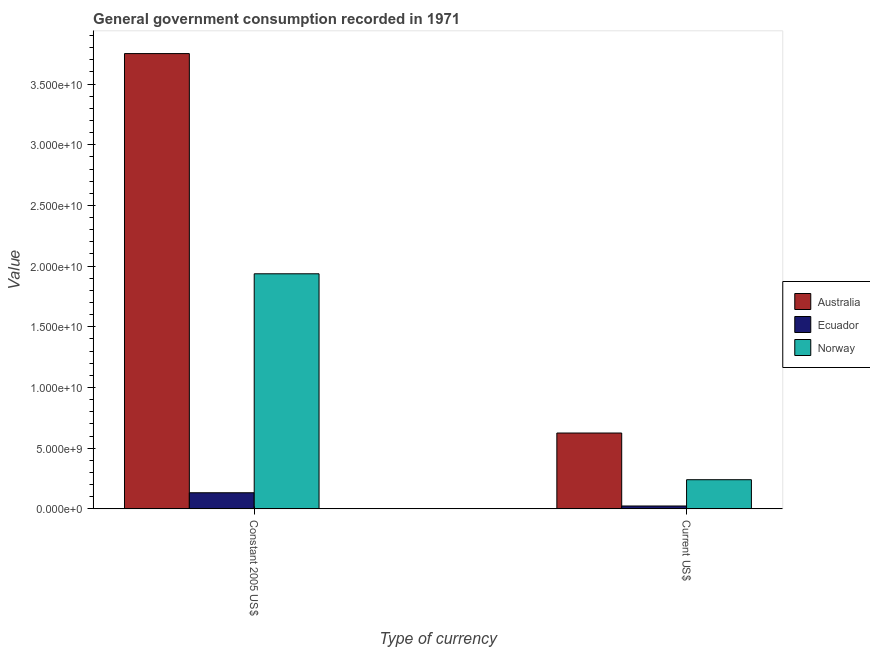How many groups of bars are there?
Your answer should be very brief. 2. How many bars are there on the 1st tick from the right?
Offer a very short reply. 3. What is the label of the 2nd group of bars from the left?
Offer a very short reply. Current US$. What is the value consumed in current us$ in Australia?
Your answer should be very brief. 6.25e+09. Across all countries, what is the maximum value consumed in current us$?
Offer a terse response. 6.25e+09. Across all countries, what is the minimum value consumed in current us$?
Your response must be concise. 2.34e+08. In which country was the value consumed in current us$ maximum?
Offer a terse response. Australia. In which country was the value consumed in constant 2005 us$ minimum?
Ensure brevity in your answer.  Ecuador. What is the total value consumed in current us$ in the graph?
Give a very brief answer. 8.88e+09. What is the difference between the value consumed in constant 2005 us$ in Australia and that in Norway?
Your answer should be very brief. 1.81e+1. What is the difference between the value consumed in constant 2005 us$ in Ecuador and the value consumed in current us$ in Norway?
Offer a very short reply. -1.07e+09. What is the average value consumed in constant 2005 us$ per country?
Give a very brief answer. 1.94e+1. What is the difference between the value consumed in constant 2005 us$ and value consumed in current us$ in Ecuador?
Offer a very short reply. 1.09e+09. In how many countries, is the value consumed in current us$ greater than 22000000000 ?
Make the answer very short. 0. What is the ratio of the value consumed in constant 2005 us$ in Norway to that in Australia?
Your answer should be very brief. 0.52. In how many countries, is the value consumed in current us$ greater than the average value consumed in current us$ taken over all countries?
Offer a terse response. 1. How many bars are there?
Offer a very short reply. 6. Are all the bars in the graph horizontal?
Provide a succinct answer. No. How many countries are there in the graph?
Give a very brief answer. 3. Are the values on the major ticks of Y-axis written in scientific E-notation?
Your answer should be very brief. Yes. Does the graph contain any zero values?
Offer a terse response. No. How are the legend labels stacked?
Provide a short and direct response. Vertical. What is the title of the graph?
Ensure brevity in your answer.  General government consumption recorded in 1971. What is the label or title of the X-axis?
Your answer should be compact. Type of currency. What is the label or title of the Y-axis?
Keep it short and to the point. Value. What is the Value in Australia in Constant 2005 US$?
Your answer should be compact. 3.75e+1. What is the Value of Ecuador in Constant 2005 US$?
Give a very brief answer. 1.33e+09. What is the Value in Norway in Constant 2005 US$?
Make the answer very short. 1.94e+1. What is the Value in Australia in Current US$?
Keep it short and to the point. 6.25e+09. What is the Value in Ecuador in Current US$?
Your answer should be very brief. 2.34e+08. What is the Value of Norway in Current US$?
Offer a terse response. 2.40e+09. Across all Type of currency, what is the maximum Value of Australia?
Make the answer very short. 3.75e+1. Across all Type of currency, what is the maximum Value in Ecuador?
Your response must be concise. 1.33e+09. Across all Type of currency, what is the maximum Value of Norway?
Provide a succinct answer. 1.94e+1. Across all Type of currency, what is the minimum Value in Australia?
Offer a very short reply. 6.25e+09. Across all Type of currency, what is the minimum Value in Ecuador?
Make the answer very short. 2.34e+08. Across all Type of currency, what is the minimum Value in Norway?
Provide a succinct answer. 2.40e+09. What is the total Value in Australia in the graph?
Offer a very short reply. 4.38e+1. What is the total Value in Ecuador in the graph?
Give a very brief answer. 1.56e+09. What is the total Value of Norway in the graph?
Provide a short and direct response. 2.18e+1. What is the difference between the Value of Australia in Constant 2005 US$ and that in Current US$?
Your answer should be very brief. 3.13e+1. What is the difference between the Value in Ecuador in Constant 2005 US$ and that in Current US$?
Make the answer very short. 1.09e+09. What is the difference between the Value in Norway in Constant 2005 US$ and that in Current US$?
Make the answer very short. 1.70e+1. What is the difference between the Value in Australia in Constant 2005 US$ and the Value in Ecuador in Current US$?
Offer a very short reply. 3.73e+1. What is the difference between the Value in Australia in Constant 2005 US$ and the Value in Norway in Current US$?
Ensure brevity in your answer.  3.51e+1. What is the difference between the Value of Ecuador in Constant 2005 US$ and the Value of Norway in Current US$?
Give a very brief answer. -1.07e+09. What is the average Value of Australia per Type of currency?
Your answer should be very brief. 2.19e+1. What is the average Value in Ecuador per Type of currency?
Offer a terse response. 7.80e+08. What is the average Value of Norway per Type of currency?
Your answer should be compact. 1.09e+1. What is the difference between the Value in Australia and Value in Ecuador in Constant 2005 US$?
Keep it short and to the point. 3.62e+1. What is the difference between the Value of Australia and Value of Norway in Constant 2005 US$?
Make the answer very short. 1.81e+1. What is the difference between the Value of Ecuador and Value of Norway in Constant 2005 US$?
Keep it short and to the point. -1.80e+1. What is the difference between the Value in Australia and Value in Ecuador in Current US$?
Make the answer very short. 6.01e+09. What is the difference between the Value of Australia and Value of Norway in Current US$?
Your answer should be compact. 3.85e+09. What is the difference between the Value of Ecuador and Value of Norway in Current US$?
Your response must be concise. -2.17e+09. What is the ratio of the Value of Australia in Constant 2005 US$ to that in Current US$?
Ensure brevity in your answer.  6. What is the ratio of the Value in Ecuador in Constant 2005 US$ to that in Current US$?
Keep it short and to the point. 5.65. What is the ratio of the Value of Norway in Constant 2005 US$ to that in Current US$?
Make the answer very short. 8.07. What is the difference between the highest and the second highest Value in Australia?
Provide a short and direct response. 3.13e+1. What is the difference between the highest and the second highest Value of Ecuador?
Give a very brief answer. 1.09e+09. What is the difference between the highest and the second highest Value of Norway?
Your answer should be very brief. 1.70e+1. What is the difference between the highest and the lowest Value in Australia?
Ensure brevity in your answer.  3.13e+1. What is the difference between the highest and the lowest Value in Ecuador?
Ensure brevity in your answer.  1.09e+09. What is the difference between the highest and the lowest Value of Norway?
Your answer should be very brief. 1.70e+1. 